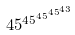<formula> <loc_0><loc_0><loc_500><loc_500>4 5 ^ { 4 5 ^ { 4 5 ^ { 4 5 ^ { 4 3 } } } }</formula> 